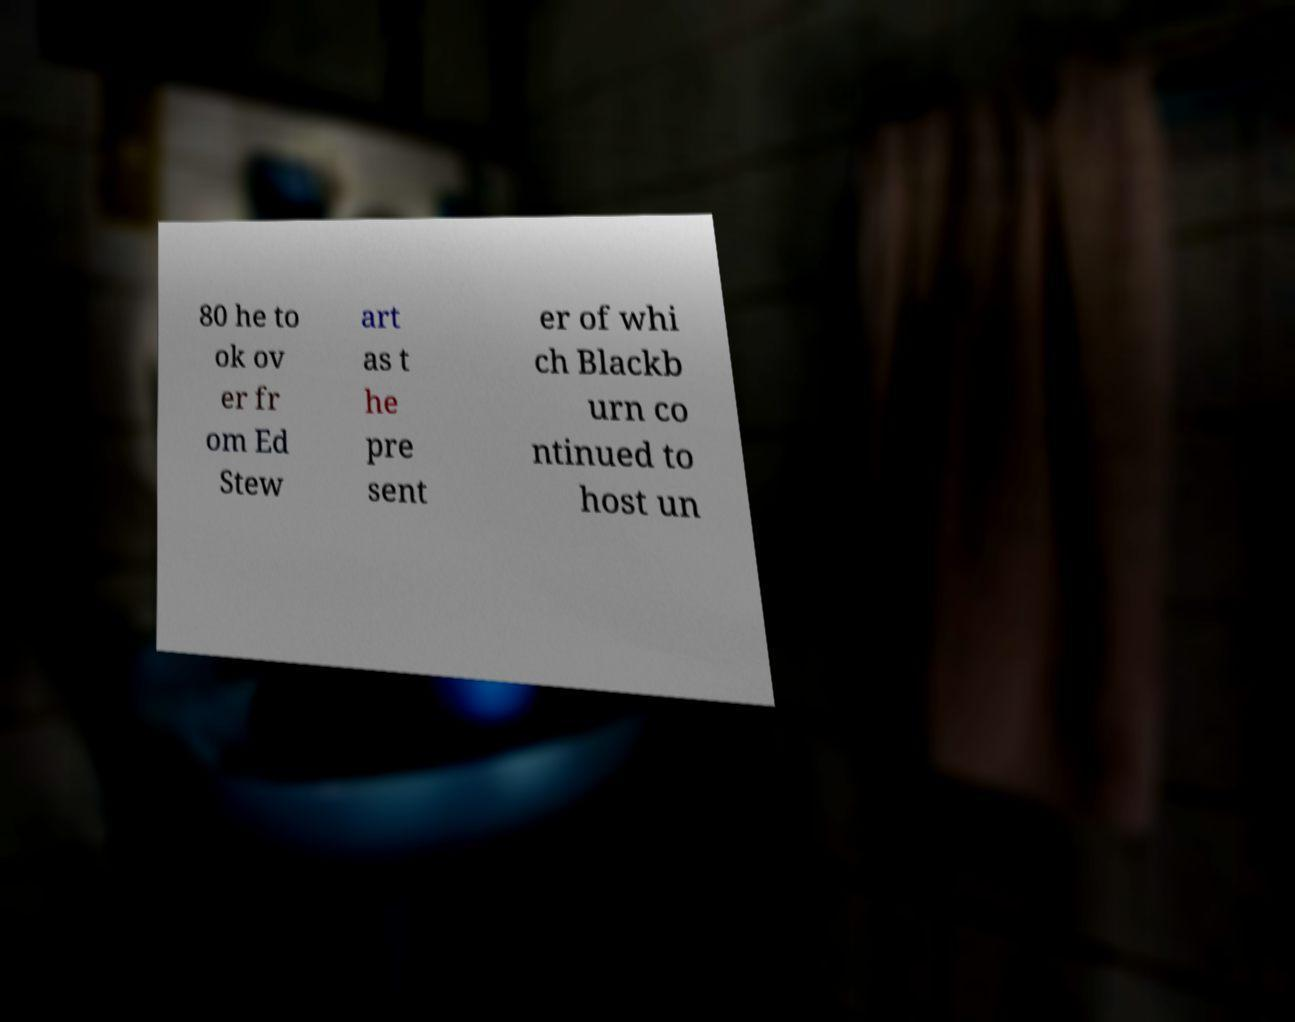Could you extract and type out the text from this image? 80 he to ok ov er fr om Ed Stew art as t he pre sent er of whi ch Blackb urn co ntinued to host un 